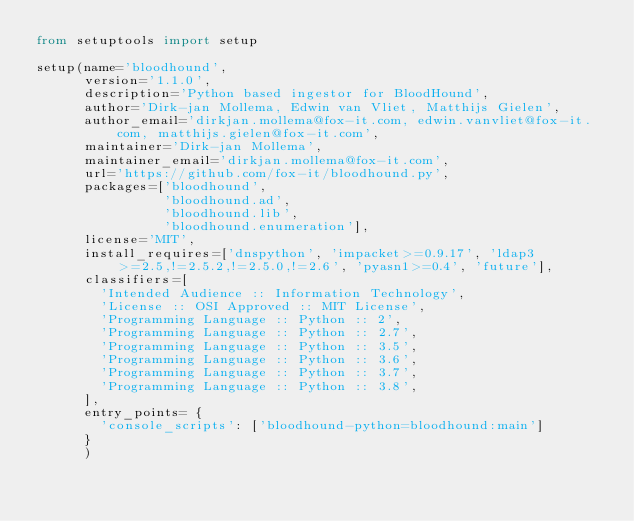Convert code to text. <code><loc_0><loc_0><loc_500><loc_500><_Python_>from setuptools import setup

setup(name='bloodhound',
      version='1.1.0',
      description='Python based ingestor for BloodHound',
      author='Dirk-jan Mollema, Edwin van Vliet, Matthijs Gielen',
      author_email='dirkjan.mollema@fox-it.com, edwin.vanvliet@fox-it.com, matthijs.gielen@fox-it.com',
      maintainer='Dirk-jan Mollema',
      maintainer_email='dirkjan.mollema@fox-it.com',
      url='https://github.com/fox-it/bloodhound.py',
      packages=['bloodhound',
                'bloodhound.ad',
                'bloodhound.lib',
                'bloodhound.enumeration'],
      license='MIT',
      install_requires=['dnspython', 'impacket>=0.9.17', 'ldap3>=2.5,!=2.5.2,!=2.5.0,!=2.6', 'pyasn1>=0.4', 'future'],
      classifiers=[
        'Intended Audience :: Information Technology',
        'License :: OSI Approved :: MIT License',
        'Programming Language :: Python :: 2',
        'Programming Language :: Python :: 2.7',
        'Programming Language :: Python :: 3.5',
        'Programming Language :: Python :: 3.6',
        'Programming Language :: Python :: 3.7',
        'Programming Language :: Python :: 3.8',
      ],
      entry_points= {
        'console_scripts': ['bloodhound-python=bloodhound:main']
      }
      )
</code> 